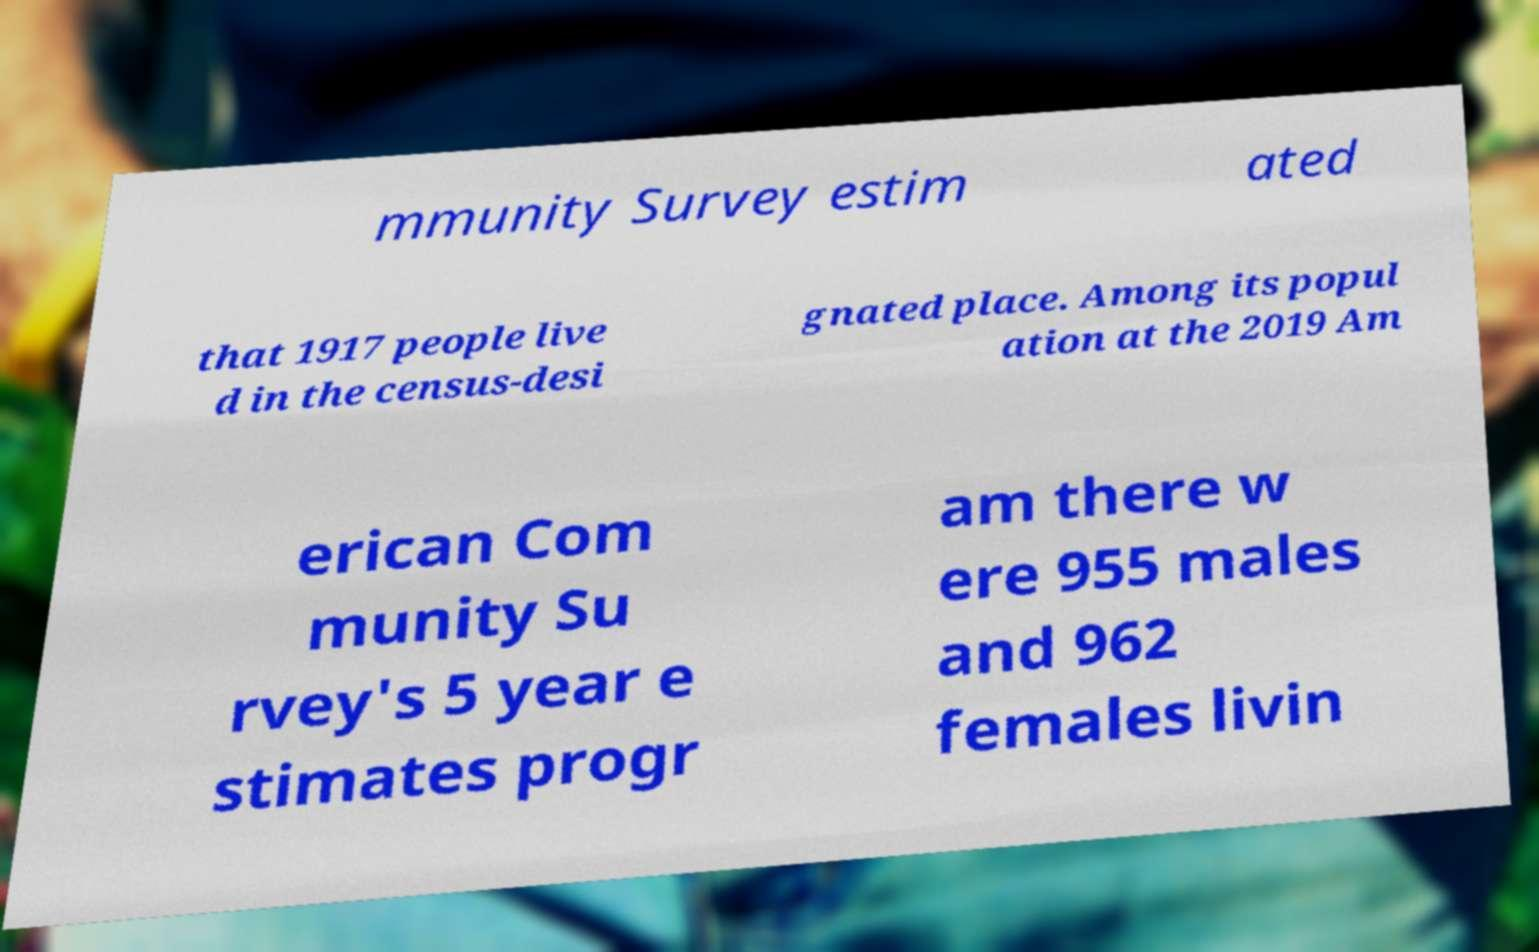Can you accurately transcribe the text from the provided image for me? mmunity Survey estim ated that 1917 people live d in the census-desi gnated place. Among its popul ation at the 2019 Am erican Com munity Su rvey's 5 year e stimates progr am there w ere 955 males and 962 females livin 